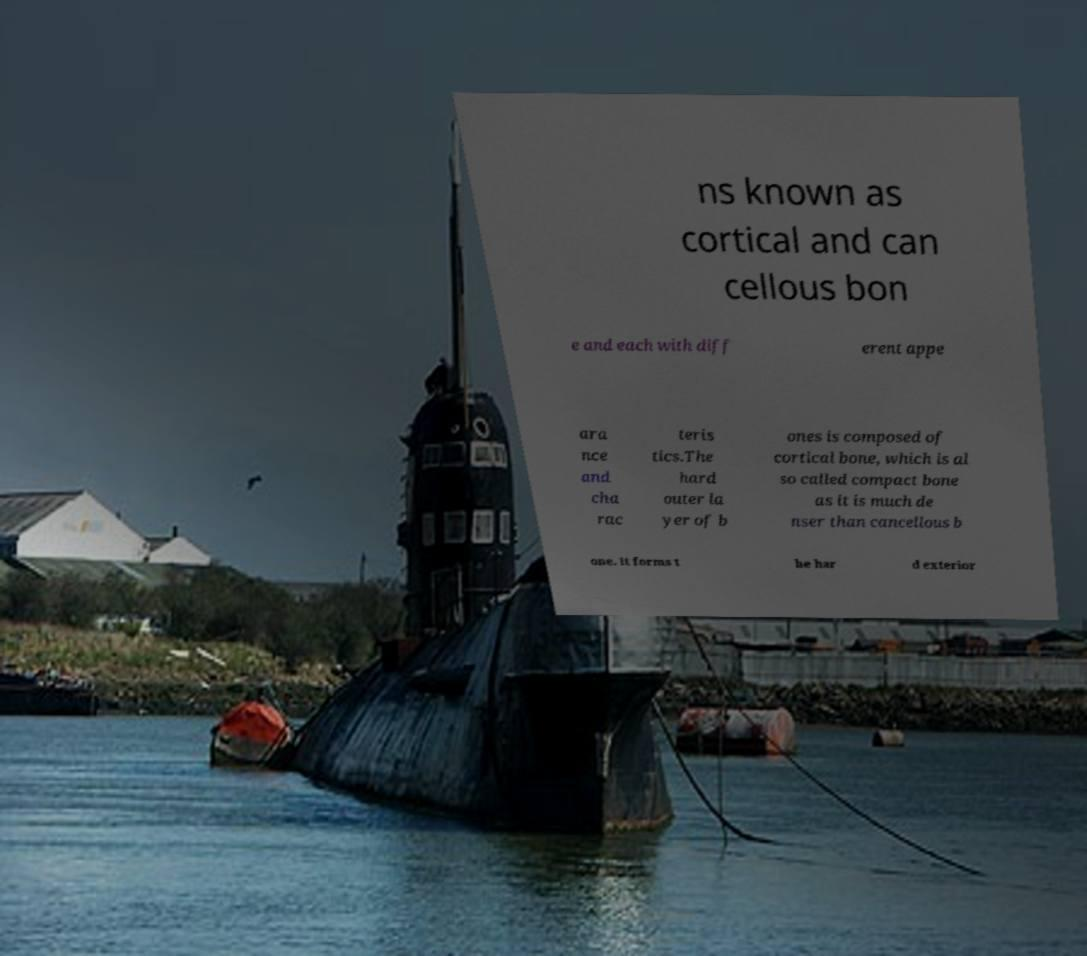Could you extract and type out the text from this image? ns known as cortical and can cellous bon e and each with diff erent appe ara nce and cha rac teris tics.The hard outer la yer of b ones is composed of cortical bone, which is al so called compact bone as it is much de nser than cancellous b one. It forms t he har d exterior 